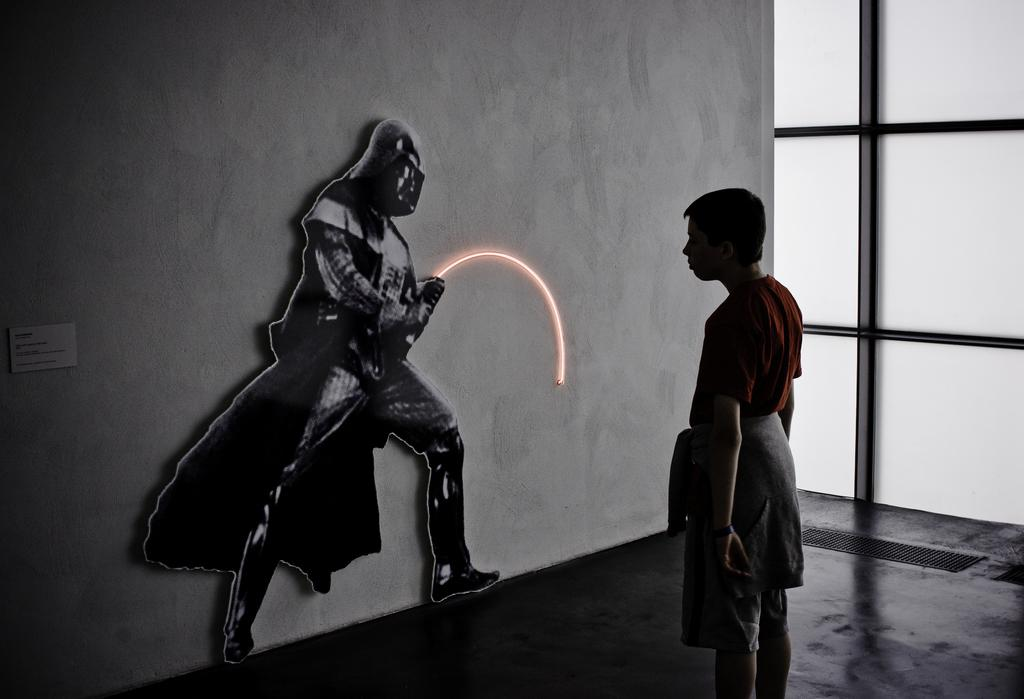What is the primary subject in the image? There is a person standing in the image. Where is the person standing? The person is standing on the floor. What can be seen on the wall in the image? There is a poster on the wall. What other objects are present in the image? There is a sticker, a glass, and a grill on the right side of the image. What color is the paint on the person's shirt in the image? There is no paint mentioned or visible on the person's shirt in the image. How does the spark from the grill affect the person in the image? There is no spark visible in the image, and therefore it cannot affect the person. 